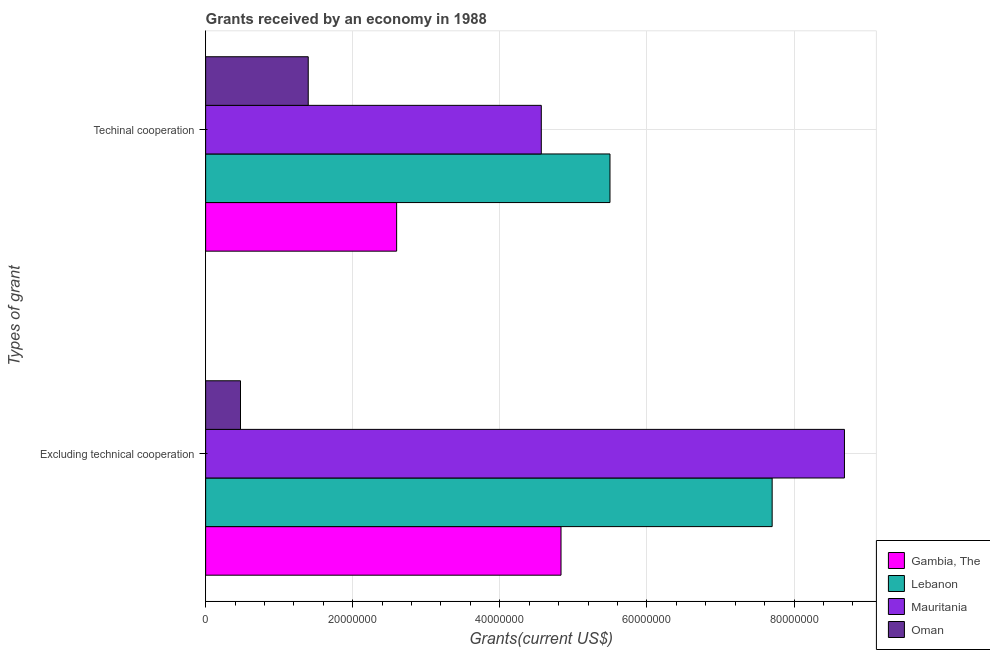How many different coloured bars are there?
Provide a short and direct response. 4. How many groups of bars are there?
Your response must be concise. 2. How many bars are there on the 1st tick from the bottom?
Provide a short and direct response. 4. What is the label of the 2nd group of bars from the top?
Your answer should be compact. Excluding technical cooperation. What is the amount of grants received(excluding technical cooperation) in Oman?
Keep it short and to the point. 4.74e+06. Across all countries, what is the maximum amount of grants received(excluding technical cooperation)?
Your answer should be compact. 8.69e+07. Across all countries, what is the minimum amount of grants received(excluding technical cooperation)?
Offer a terse response. 4.74e+06. In which country was the amount of grants received(excluding technical cooperation) maximum?
Offer a terse response. Mauritania. In which country was the amount of grants received(excluding technical cooperation) minimum?
Give a very brief answer. Oman. What is the total amount of grants received(excluding technical cooperation) in the graph?
Provide a short and direct response. 2.17e+08. What is the difference between the amount of grants received(excluding technical cooperation) in Oman and that in Lebanon?
Your answer should be very brief. -7.23e+07. What is the difference between the amount of grants received(including technical cooperation) in Mauritania and the amount of grants received(excluding technical cooperation) in Gambia, The?
Your response must be concise. -2.68e+06. What is the average amount of grants received(excluding technical cooperation) per country?
Give a very brief answer. 5.42e+07. What is the difference between the amount of grants received(excluding technical cooperation) and amount of grants received(including technical cooperation) in Gambia, The?
Offer a terse response. 2.24e+07. In how many countries, is the amount of grants received(including technical cooperation) greater than 32000000 US$?
Offer a very short reply. 2. What is the ratio of the amount of grants received(excluding technical cooperation) in Gambia, The to that in Mauritania?
Your answer should be compact. 0.56. In how many countries, is the amount of grants received(excluding technical cooperation) greater than the average amount of grants received(excluding technical cooperation) taken over all countries?
Your answer should be very brief. 2. What does the 4th bar from the top in Excluding technical cooperation represents?
Your response must be concise. Gambia, The. What does the 4th bar from the bottom in Excluding technical cooperation represents?
Your response must be concise. Oman. How many bars are there?
Provide a succinct answer. 8. Are all the bars in the graph horizontal?
Provide a short and direct response. Yes. Are the values on the major ticks of X-axis written in scientific E-notation?
Provide a short and direct response. No. Does the graph contain any zero values?
Give a very brief answer. No. Does the graph contain grids?
Offer a very short reply. Yes. How many legend labels are there?
Keep it short and to the point. 4. How are the legend labels stacked?
Ensure brevity in your answer.  Vertical. What is the title of the graph?
Provide a succinct answer. Grants received by an economy in 1988. What is the label or title of the X-axis?
Provide a short and direct response. Grants(current US$). What is the label or title of the Y-axis?
Keep it short and to the point. Types of grant. What is the Grants(current US$) of Gambia, The in Excluding technical cooperation?
Provide a short and direct response. 4.83e+07. What is the Grants(current US$) in Lebanon in Excluding technical cooperation?
Offer a terse response. 7.70e+07. What is the Grants(current US$) in Mauritania in Excluding technical cooperation?
Your response must be concise. 8.69e+07. What is the Grants(current US$) in Oman in Excluding technical cooperation?
Make the answer very short. 4.74e+06. What is the Grants(current US$) of Gambia, The in Techinal cooperation?
Offer a very short reply. 2.60e+07. What is the Grants(current US$) in Lebanon in Techinal cooperation?
Offer a very short reply. 5.50e+07. What is the Grants(current US$) of Mauritania in Techinal cooperation?
Your answer should be very brief. 4.56e+07. What is the Grants(current US$) of Oman in Techinal cooperation?
Your response must be concise. 1.40e+07. Across all Types of grant, what is the maximum Grants(current US$) of Gambia, The?
Offer a very short reply. 4.83e+07. Across all Types of grant, what is the maximum Grants(current US$) in Lebanon?
Your answer should be compact. 7.70e+07. Across all Types of grant, what is the maximum Grants(current US$) in Mauritania?
Provide a succinct answer. 8.69e+07. Across all Types of grant, what is the maximum Grants(current US$) in Oman?
Provide a succinct answer. 1.40e+07. Across all Types of grant, what is the minimum Grants(current US$) of Gambia, The?
Your response must be concise. 2.60e+07. Across all Types of grant, what is the minimum Grants(current US$) in Lebanon?
Your answer should be compact. 5.50e+07. Across all Types of grant, what is the minimum Grants(current US$) in Mauritania?
Your response must be concise. 4.56e+07. Across all Types of grant, what is the minimum Grants(current US$) of Oman?
Your response must be concise. 4.74e+06. What is the total Grants(current US$) of Gambia, The in the graph?
Keep it short and to the point. 7.43e+07. What is the total Grants(current US$) of Lebanon in the graph?
Your answer should be very brief. 1.32e+08. What is the total Grants(current US$) of Mauritania in the graph?
Provide a short and direct response. 1.32e+08. What is the total Grants(current US$) of Oman in the graph?
Ensure brevity in your answer.  1.87e+07. What is the difference between the Grants(current US$) in Gambia, The in Excluding technical cooperation and that in Techinal cooperation?
Provide a short and direct response. 2.24e+07. What is the difference between the Grants(current US$) in Lebanon in Excluding technical cooperation and that in Techinal cooperation?
Ensure brevity in your answer.  2.20e+07. What is the difference between the Grants(current US$) in Mauritania in Excluding technical cooperation and that in Techinal cooperation?
Offer a terse response. 4.12e+07. What is the difference between the Grants(current US$) in Oman in Excluding technical cooperation and that in Techinal cooperation?
Give a very brief answer. -9.21e+06. What is the difference between the Grants(current US$) of Gambia, The in Excluding technical cooperation and the Grants(current US$) of Lebanon in Techinal cooperation?
Your answer should be very brief. -6.66e+06. What is the difference between the Grants(current US$) of Gambia, The in Excluding technical cooperation and the Grants(current US$) of Mauritania in Techinal cooperation?
Make the answer very short. 2.68e+06. What is the difference between the Grants(current US$) of Gambia, The in Excluding technical cooperation and the Grants(current US$) of Oman in Techinal cooperation?
Ensure brevity in your answer.  3.44e+07. What is the difference between the Grants(current US$) in Lebanon in Excluding technical cooperation and the Grants(current US$) in Mauritania in Techinal cooperation?
Keep it short and to the point. 3.14e+07. What is the difference between the Grants(current US$) of Lebanon in Excluding technical cooperation and the Grants(current US$) of Oman in Techinal cooperation?
Give a very brief answer. 6.31e+07. What is the difference between the Grants(current US$) of Mauritania in Excluding technical cooperation and the Grants(current US$) of Oman in Techinal cooperation?
Keep it short and to the point. 7.29e+07. What is the average Grants(current US$) of Gambia, The per Types of grant?
Offer a very short reply. 3.71e+07. What is the average Grants(current US$) in Lebanon per Types of grant?
Your response must be concise. 6.60e+07. What is the average Grants(current US$) of Mauritania per Types of grant?
Your response must be concise. 6.62e+07. What is the average Grants(current US$) of Oman per Types of grant?
Offer a terse response. 9.34e+06. What is the difference between the Grants(current US$) in Gambia, The and Grants(current US$) in Lebanon in Excluding technical cooperation?
Make the answer very short. -2.87e+07. What is the difference between the Grants(current US$) in Gambia, The and Grants(current US$) in Mauritania in Excluding technical cooperation?
Give a very brief answer. -3.85e+07. What is the difference between the Grants(current US$) of Gambia, The and Grants(current US$) of Oman in Excluding technical cooperation?
Keep it short and to the point. 4.36e+07. What is the difference between the Grants(current US$) in Lebanon and Grants(current US$) in Mauritania in Excluding technical cooperation?
Your answer should be very brief. -9.83e+06. What is the difference between the Grants(current US$) of Lebanon and Grants(current US$) of Oman in Excluding technical cooperation?
Offer a very short reply. 7.23e+07. What is the difference between the Grants(current US$) in Mauritania and Grants(current US$) in Oman in Excluding technical cooperation?
Your answer should be very brief. 8.21e+07. What is the difference between the Grants(current US$) in Gambia, The and Grants(current US$) in Lebanon in Techinal cooperation?
Keep it short and to the point. -2.90e+07. What is the difference between the Grants(current US$) of Gambia, The and Grants(current US$) of Mauritania in Techinal cooperation?
Keep it short and to the point. -1.97e+07. What is the difference between the Grants(current US$) of Gambia, The and Grants(current US$) of Oman in Techinal cooperation?
Your response must be concise. 1.20e+07. What is the difference between the Grants(current US$) of Lebanon and Grants(current US$) of Mauritania in Techinal cooperation?
Your answer should be very brief. 9.34e+06. What is the difference between the Grants(current US$) in Lebanon and Grants(current US$) in Oman in Techinal cooperation?
Keep it short and to the point. 4.10e+07. What is the difference between the Grants(current US$) in Mauritania and Grants(current US$) in Oman in Techinal cooperation?
Make the answer very short. 3.17e+07. What is the ratio of the Grants(current US$) in Gambia, The in Excluding technical cooperation to that in Techinal cooperation?
Your answer should be very brief. 1.86. What is the ratio of the Grants(current US$) of Lebanon in Excluding technical cooperation to that in Techinal cooperation?
Ensure brevity in your answer.  1.4. What is the ratio of the Grants(current US$) in Mauritania in Excluding technical cooperation to that in Techinal cooperation?
Make the answer very short. 1.9. What is the ratio of the Grants(current US$) in Oman in Excluding technical cooperation to that in Techinal cooperation?
Ensure brevity in your answer.  0.34. What is the difference between the highest and the second highest Grants(current US$) of Gambia, The?
Provide a short and direct response. 2.24e+07. What is the difference between the highest and the second highest Grants(current US$) in Lebanon?
Provide a succinct answer. 2.20e+07. What is the difference between the highest and the second highest Grants(current US$) of Mauritania?
Give a very brief answer. 4.12e+07. What is the difference between the highest and the second highest Grants(current US$) of Oman?
Provide a succinct answer. 9.21e+06. What is the difference between the highest and the lowest Grants(current US$) in Gambia, The?
Offer a very short reply. 2.24e+07. What is the difference between the highest and the lowest Grants(current US$) in Lebanon?
Make the answer very short. 2.20e+07. What is the difference between the highest and the lowest Grants(current US$) of Mauritania?
Your answer should be very brief. 4.12e+07. What is the difference between the highest and the lowest Grants(current US$) of Oman?
Keep it short and to the point. 9.21e+06. 